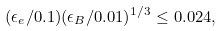Convert formula to latex. <formula><loc_0><loc_0><loc_500><loc_500>( \epsilon _ { e } / 0 . 1 ) ( \epsilon _ { B } / 0 . 0 1 ) ^ { 1 / 3 } \leq 0 . 0 2 4 ,</formula> 